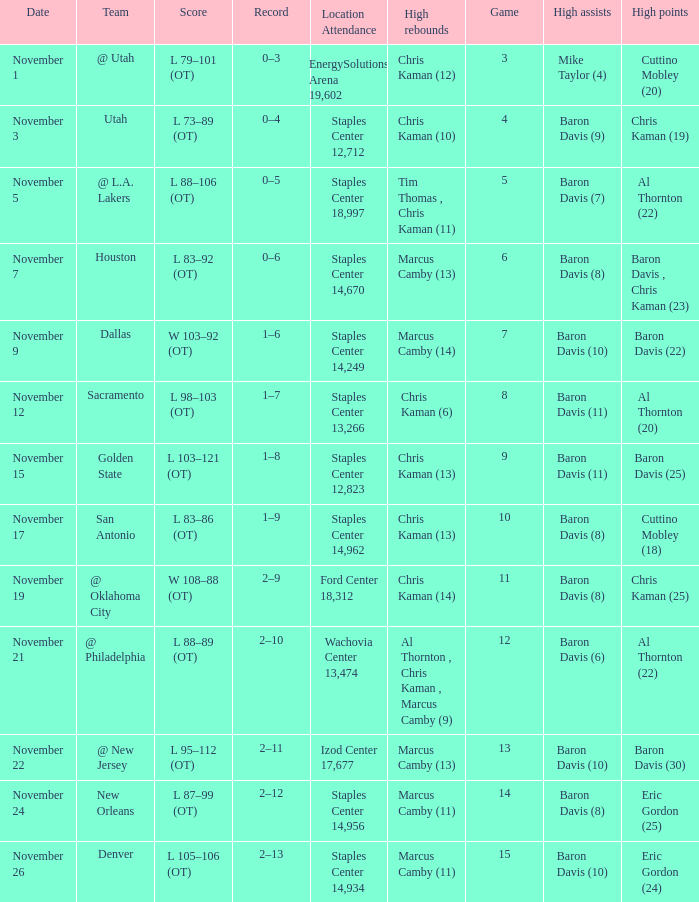Name the total number of score for staples center 13,266 1.0. 